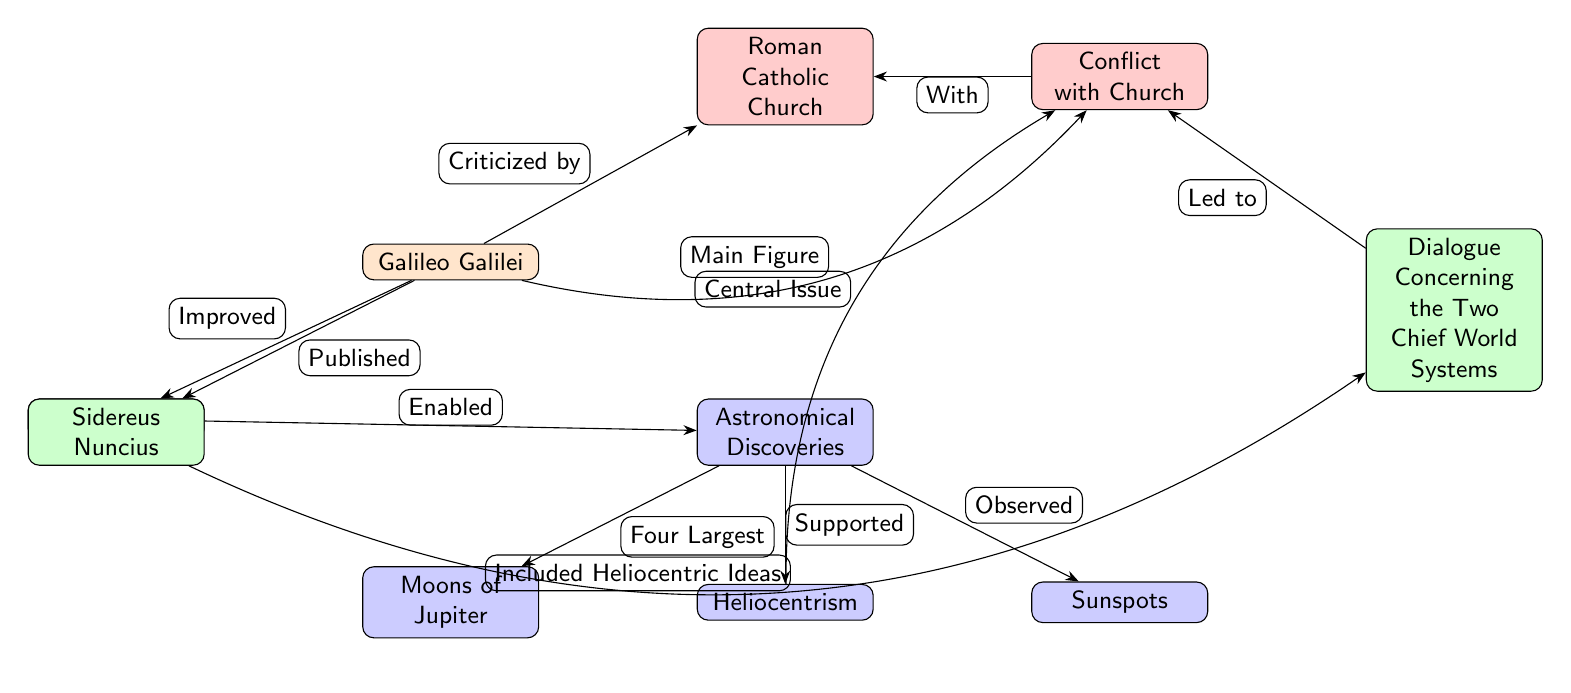What is the main figure in the conflict with the church? The main figure in the conflict with the church is Galileo Galilei, as indicated by the edge labeled "Main Figure" pointing from Galileo to the conflict node.
Answer: Galileo Galilei How many significant astronomical discoveries are shown? The diagram shows three significant astronomical discoveries: Heliocentrism, Moons of Jupiter, and Sunspots. Counting the nodes directly related to discoveries confirms this.
Answer: Three What work did Galileo publish that is related to heliocentric ideas? Galileo published "Sidereus Nuncius," which is connected to the "Included Heliocentric Ideas" edge to "Dialogue Concerning the Two Chief World Systems."
Answer: Sidereus Nuncius What role did the telescope play in Galileo's discoveries? The telescope played an enabling role, as illustrated by the edge labeled "Enabled" pointing from the telescope to the astronomical discoveries.
Answer: Enabled What is described as the central issue in the conflict with the church? The diagram indicates that "Heliocentrism" is the central issue in the conflict, as represented by the edge labeled "Central Issue" linking heliocentrism to the conflict with the church.
Answer: Heliocentrism Which nodes lead to the conflict with the church? The conflict is led to by the "Dialogue Concerning the Two Chief World Systems," connected through the edge labeled "Led to," and stems from Galileo's criticisms, as shown by the relevant edges flowing from Galileo and discoveries.
Answer: Dialogue Concerning the Two Chief World Systems What astronomical discovery is associated with the moons of Jupiter? The discovery associated with the moons of Jupiter is "Four Largest," as indicated by the edge flowing from the discoveries node to the moons node.
Answer: Four Largest Who criticized Galileo's work? Galileo's work was criticized by the "Roman Catholic Church," as shown by the edge labeled "Criticized by" pointing from Galileo to the church node.
Answer: Roman Catholic Church What significant publication is mentioned in the diagram? The significant publication mentioned in the diagram is "Dialogue Concerning the Two Chief World Systems," as identified in the work node connected to the conflict.
Answer: Dialogue Concerning the Two Chief World Systems 